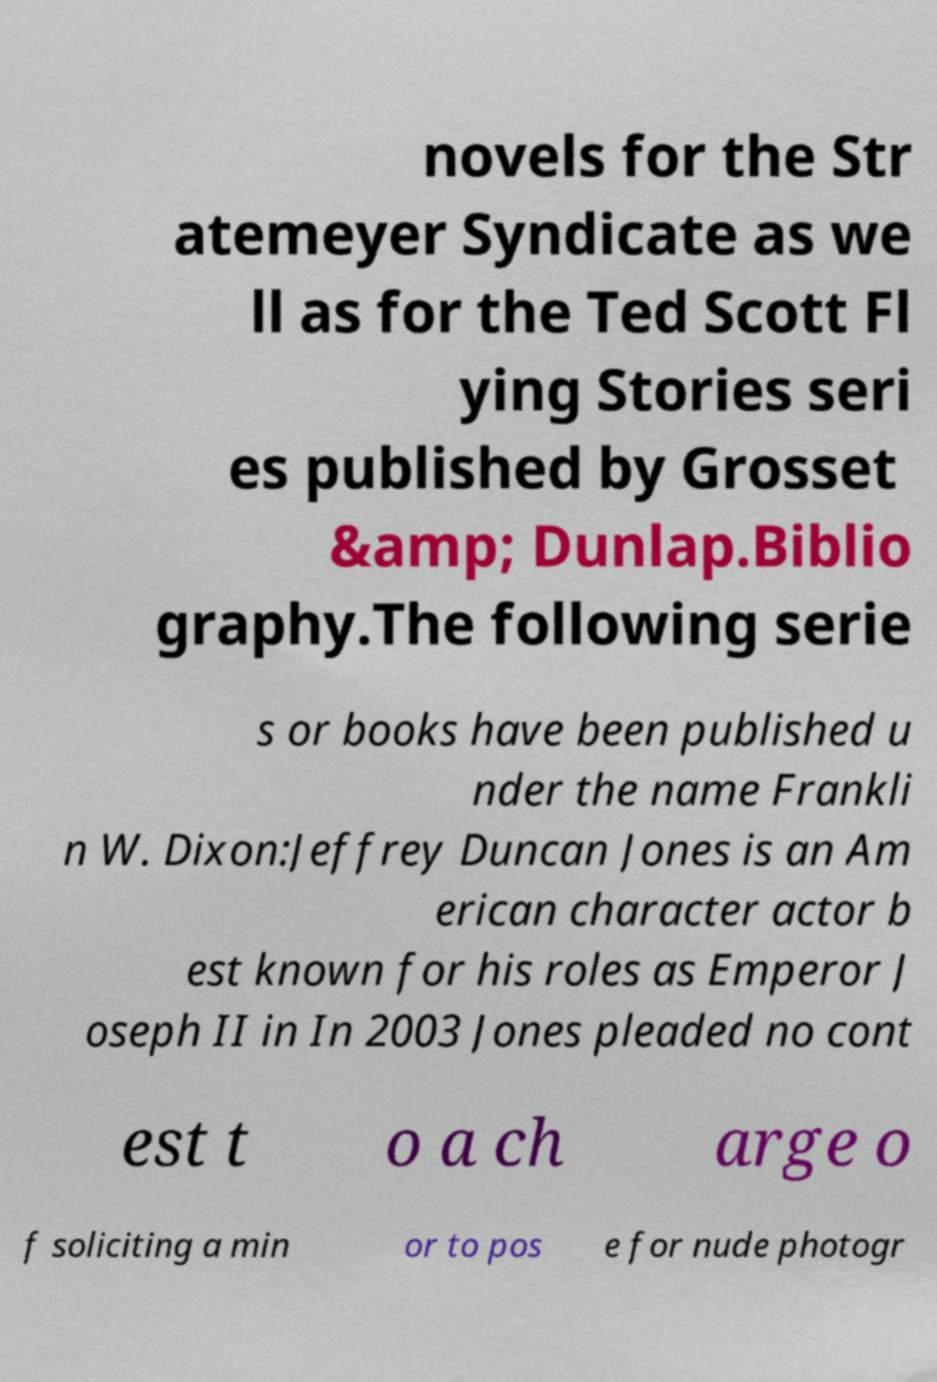Could you extract and type out the text from this image? novels for the Str atemeyer Syndicate as we ll as for the Ted Scott Fl ying Stories seri es published by Grosset &amp; Dunlap.Biblio graphy.The following serie s or books have been published u nder the name Frankli n W. Dixon:Jeffrey Duncan Jones is an Am erican character actor b est known for his roles as Emperor J oseph II in In 2003 Jones pleaded no cont est t o a ch arge o f soliciting a min or to pos e for nude photogr 